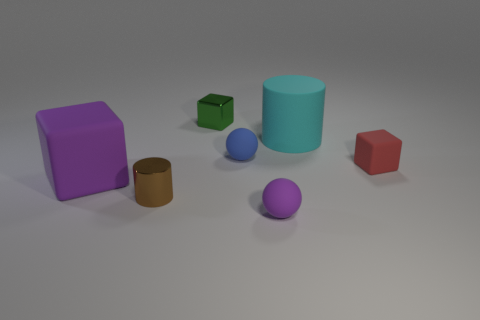What is the material of the small ball that is the same color as the big block?
Provide a short and direct response. Rubber. What number of other things are there of the same color as the large block?
Make the answer very short. 1. Are there fewer big purple rubber cubes behind the red rubber thing than small green metallic things on the right side of the green thing?
Offer a terse response. No. There is a small object that is in front of the small red matte object and behind the purple matte sphere; what shape is it?
Your response must be concise. Cylinder. How many tiny brown metal things are the same shape as the large cyan rubber thing?
Ensure brevity in your answer.  1. There is a ball that is made of the same material as the tiny purple thing; what is its size?
Ensure brevity in your answer.  Small. Are there more small red blocks than objects?
Make the answer very short. No. What color is the big rubber object that is in front of the red rubber object?
Make the answer very short. Purple. What is the size of the thing that is behind the brown cylinder and on the left side of the green shiny thing?
Your answer should be compact. Large. What number of brown metallic objects are the same size as the red thing?
Offer a very short reply. 1. 